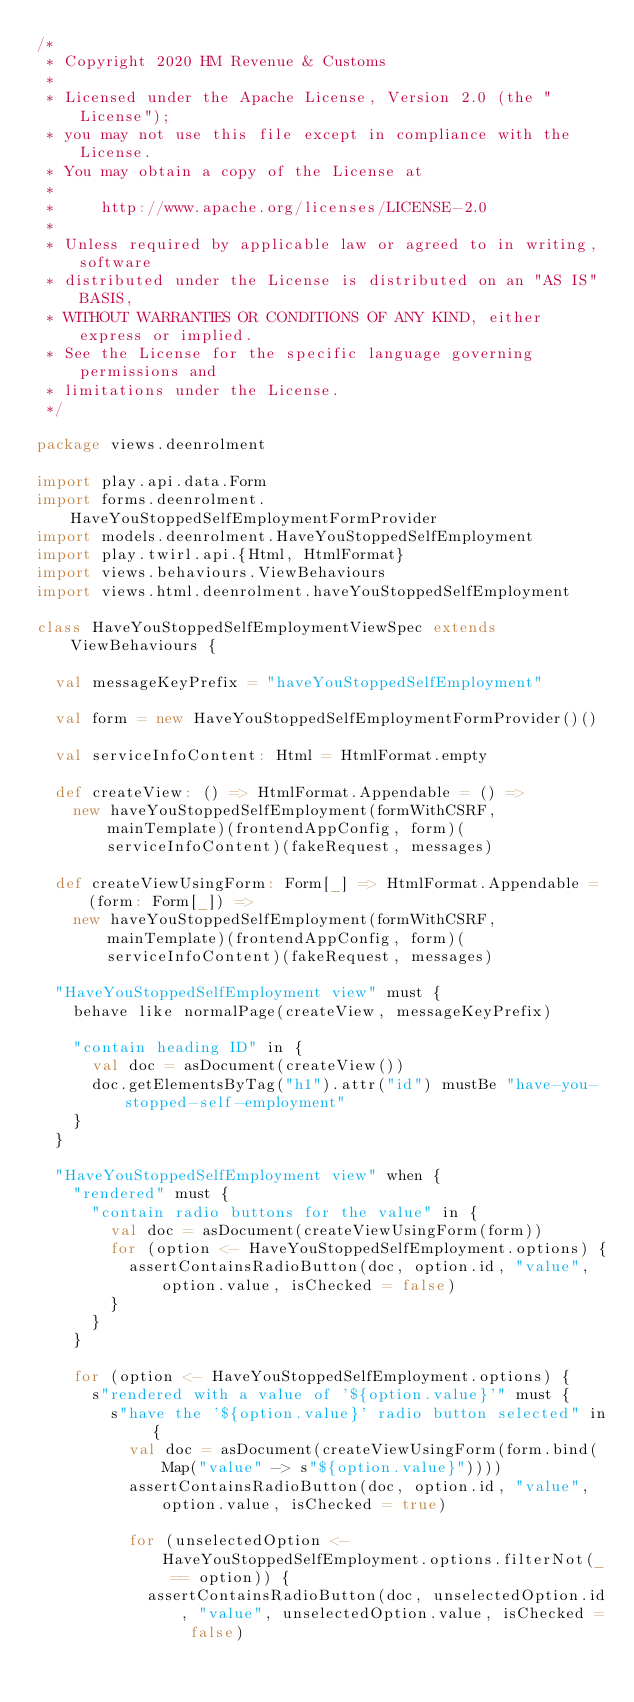<code> <loc_0><loc_0><loc_500><loc_500><_Scala_>/*
 * Copyright 2020 HM Revenue & Customs
 *
 * Licensed under the Apache License, Version 2.0 (the "License");
 * you may not use this file except in compliance with the License.
 * You may obtain a copy of the License at
 *
 *     http://www.apache.org/licenses/LICENSE-2.0
 *
 * Unless required by applicable law or agreed to in writing, software
 * distributed under the License is distributed on an "AS IS" BASIS,
 * WITHOUT WARRANTIES OR CONDITIONS OF ANY KIND, either express or implied.
 * See the License for the specific language governing permissions and
 * limitations under the License.
 */

package views.deenrolment

import play.api.data.Form
import forms.deenrolment.HaveYouStoppedSelfEmploymentFormProvider
import models.deenrolment.HaveYouStoppedSelfEmployment
import play.twirl.api.{Html, HtmlFormat}
import views.behaviours.ViewBehaviours
import views.html.deenrolment.haveYouStoppedSelfEmployment

class HaveYouStoppedSelfEmploymentViewSpec extends ViewBehaviours {

  val messageKeyPrefix = "haveYouStoppedSelfEmployment"

  val form = new HaveYouStoppedSelfEmploymentFormProvider()()

  val serviceInfoContent: Html = HtmlFormat.empty

  def createView: () => HtmlFormat.Appendable = () =>
    new haveYouStoppedSelfEmployment(formWithCSRF, mainTemplate)(frontendAppConfig, form)(serviceInfoContent)(fakeRequest, messages)

  def createViewUsingForm: Form[_] => HtmlFormat.Appendable = (form: Form[_]) =>
    new haveYouStoppedSelfEmployment(formWithCSRF, mainTemplate)(frontendAppConfig, form)(serviceInfoContent)(fakeRequest, messages)

  "HaveYouStoppedSelfEmployment view" must {
    behave like normalPage(createView, messageKeyPrefix)

    "contain heading ID" in {
      val doc = asDocument(createView())
      doc.getElementsByTag("h1").attr("id") mustBe "have-you-stopped-self-employment"
    }
  }

  "HaveYouStoppedSelfEmployment view" when {
    "rendered" must {
      "contain radio buttons for the value" in {
        val doc = asDocument(createViewUsingForm(form))
        for (option <- HaveYouStoppedSelfEmployment.options) {
          assertContainsRadioButton(doc, option.id, "value", option.value, isChecked = false)
        }
      }
    }

    for (option <- HaveYouStoppedSelfEmployment.options) {
      s"rendered with a value of '${option.value}'" must {
        s"have the '${option.value}' radio button selected" in {
          val doc = asDocument(createViewUsingForm(form.bind(Map("value" -> s"${option.value}"))))
          assertContainsRadioButton(doc, option.id, "value", option.value, isChecked = true)

          for (unselectedOption <- HaveYouStoppedSelfEmployment.options.filterNot(_ == option)) {
            assertContainsRadioButton(doc, unselectedOption.id, "value", unselectedOption.value, isChecked = false)</code> 